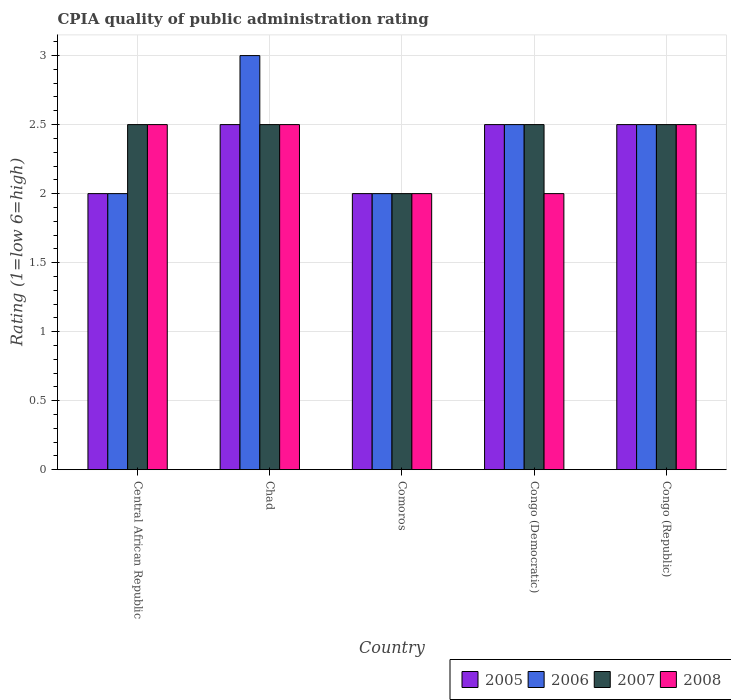How many different coloured bars are there?
Your answer should be compact. 4. How many groups of bars are there?
Your answer should be very brief. 5. Are the number of bars per tick equal to the number of legend labels?
Provide a short and direct response. Yes. Are the number of bars on each tick of the X-axis equal?
Offer a very short reply. Yes. How many bars are there on the 4th tick from the left?
Make the answer very short. 4. How many bars are there on the 1st tick from the right?
Provide a succinct answer. 4. What is the label of the 3rd group of bars from the left?
Offer a terse response. Comoros. Across all countries, what is the maximum CPIA rating in 2005?
Give a very brief answer. 2.5. Across all countries, what is the minimum CPIA rating in 2008?
Offer a terse response. 2. In which country was the CPIA rating in 2007 maximum?
Ensure brevity in your answer.  Central African Republic. In which country was the CPIA rating in 2005 minimum?
Keep it short and to the point. Central African Republic. What is the total CPIA rating in 2005 in the graph?
Provide a succinct answer. 11.5. What is the difference between the CPIA rating in 2008 in Comoros and the CPIA rating in 2006 in Congo (Republic)?
Offer a very short reply. -0.5. What is the average CPIA rating in 2006 per country?
Make the answer very short. 2.4. What is the difference between the CPIA rating of/in 2006 and CPIA rating of/in 2005 in Congo (Democratic)?
Offer a terse response. 0. What is the ratio of the CPIA rating in 2005 in Central African Republic to that in Congo (Republic)?
Make the answer very short. 0.8. Is the difference between the CPIA rating in 2006 in Comoros and Congo (Democratic) greater than the difference between the CPIA rating in 2005 in Comoros and Congo (Democratic)?
Offer a very short reply. No. What is the difference between the highest and the second highest CPIA rating in 2006?
Your answer should be compact. -0.5. What is the difference between the highest and the lowest CPIA rating in 2006?
Keep it short and to the point. 1. In how many countries, is the CPIA rating in 2008 greater than the average CPIA rating in 2008 taken over all countries?
Give a very brief answer. 3. Is the sum of the CPIA rating in 2005 in Comoros and Congo (Republic) greater than the maximum CPIA rating in 2008 across all countries?
Provide a short and direct response. Yes. Are all the bars in the graph horizontal?
Keep it short and to the point. No. Are the values on the major ticks of Y-axis written in scientific E-notation?
Your response must be concise. No. Does the graph contain grids?
Your response must be concise. Yes. Where does the legend appear in the graph?
Your answer should be compact. Bottom right. How many legend labels are there?
Your response must be concise. 4. What is the title of the graph?
Your response must be concise. CPIA quality of public administration rating. Does "1990" appear as one of the legend labels in the graph?
Your answer should be compact. No. What is the label or title of the X-axis?
Provide a short and direct response. Country. What is the Rating (1=low 6=high) in 2005 in Central African Republic?
Provide a succinct answer. 2. What is the Rating (1=low 6=high) of 2006 in Central African Republic?
Offer a terse response. 2. What is the Rating (1=low 6=high) of 2008 in Central African Republic?
Provide a succinct answer. 2.5. What is the Rating (1=low 6=high) in 2005 in Chad?
Make the answer very short. 2.5. What is the Rating (1=low 6=high) in 2006 in Chad?
Your answer should be compact. 3. What is the Rating (1=low 6=high) of 2007 in Chad?
Give a very brief answer. 2.5. What is the Rating (1=low 6=high) of 2008 in Chad?
Keep it short and to the point. 2.5. What is the Rating (1=low 6=high) in 2005 in Comoros?
Your answer should be very brief. 2. What is the Rating (1=low 6=high) in 2006 in Comoros?
Make the answer very short. 2. What is the Rating (1=low 6=high) of 2006 in Congo (Democratic)?
Keep it short and to the point. 2.5. What is the Rating (1=low 6=high) in 2008 in Congo (Democratic)?
Give a very brief answer. 2. What is the Rating (1=low 6=high) of 2005 in Congo (Republic)?
Ensure brevity in your answer.  2.5. What is the Rating (1=low 6=high) of 2007 in Congo (Republic)?
Your answer should be very brief. 2.5. Across all countries, what is the maximum Rating (1=low 6=high) in 2005?
Offer a very short reply. 2.5. Across all countries, what is the maximum Rating (1=low 6=high) of 2006?
Make the answer very short. 3. Across all countries, what is the maximum Rating (1=low 6=high) of 2007?
Provide a short and direct response. 2.5. Across all countries, what is the minimum Rating (1=low 6=high) of 2005?
Provide a short and direct response. 2. Across all countries, what is the minimum Rating (1=low 6=high) of 2006?
Ensure brevity in your answer.  2. What is the total Rating (1=low 6=high) in 2007 in the graph?
Your answer should be very brief. 12. What is the total Rating (1=low 6=high) in 2008 in the graph?
Your answer should be very brief. 11.5. What is the difference between the Rating (1=low 6=high) in 2006 in Central African Republic and that in Chad?
Make the answer very short. -1. What is the difference between the Rating (1=low 6=high) of 2005 in Central African Republic and that in Comoros?
Offer a very short reply. 0. What is the difference between the Rating (1=low 6=high) of 2006 in Central African Republic and that in Comoros?
Provide a short and direct response. 0. What is the difference between the Rating (1=low 6=high) in 2007 in Central African Republic and that in Congo (Democratic)?
Provide a succinct answer. 0. What is the difference between the Rating (1=low 6=high) in 2005 in Central African Republic and that in Congo (Republic)?
Give a very brief answer. -0.5. What is the difference between the Rating (1=low 6=high) in 2006 in Central African Republic and that in Congo (Republic)?
Your answer should be very brief. -0.5. What is the difference between the Rating (1=low 6=high) of 2008 in Central African Republic and that in Congo (Republic)?
Your response must be concise. 0. What is the difference between the Rating (1=low 6=high) in 2005 in Chad and that in Comoros?
Your answer should be compact. 0.5. What is the difference between the Rating (1=low 6=high) in 2005 in Chad and that in Congo (Democratic)?
Ensure brevity in your answer.  0. What is the difference between the Rating (1=low 6=high) in 2006 in Chad and that in Congo (Democratic)?
Keep it short and to the point. 0.5. What is the difference between the Rating (1=low 6=high) in 2007 in Chad and that in Congo (Democratic)?
Your response must be concise. 0. What is the difference between the Rating (1=low 6=high) in 2008 in Chad and that in Congo (Democratic)?
Give a very brief answer. 0.5. What is the difference between the Rating (1=low 6=high) of 2005 in Chad and that in Congo (Republic)?
Make the answer very short. 0. What is the difference between the Rating (1=low 6=high) in 2006 in Chad and that in Congo (Republic)?
Your answer should be compact. 0.5. What is the difference between the Rating (1=low 6=high) in 2007 in Chad and that in Congo (Republic)?
Keep it short and to the point. 0. What is the difference between the Rating (1=low 6=high) in 2005 in Comoros and that in Congo (Democratic)?
Offer a very short reply. -0.5. What is the difference between the Rating (1=low 6=high) of 2005 in Comoros and that in Congo (Republic)?
Keep it short and to the point. -0.5. What is the difference between the Rating (1=low 6=high) in 2007 in Comoros and that in Congo (Republic)?
Your answer should be very brief. -0.5. What is the difference between the Rating (1=low 6=high) of 2008 in Comoros and that in Congo (Republic)?
Make the answer very short. -0.5. What is the difference between the Rating (1=low 6=high) of 2006 in Congo (Democratic) and that in Congo (Republic)?
Your response must be concise. 0. What is the difference between the Rating (1=low 6=high) in 2008 in Congo (Democratic) and that in Congo (Republic)?
Your answer should be compact. -0.5. What is the difference between the Rating (1=low 6=high) of 2005 in Central African Republic and the Rating (1=low 6=high) of 2007 in Chad?
Offer a terse response. -0.5. What is the difference between the Rating (1=low 6=high) in 2005 in Central African Republic and the Rating (1=low 6=high) in 2008 in Chad?
Your answer should be compact. -0.5. What is the difference between the Rating (1=low 6=high) of 2006 in Central African Republic and the Rating (1=low 6=high) of 2007 in Chad?
Offer a very short reply. -0.5. What is the difference between the Rating (1=low 6=high) of 2006 in Central African Republic and the Rating (1=low 6=high) of 2008 in Chad?
Make the answer very short. -0.5. What is the difference between the Rating (1=low 6=high) of 2005 in Central African Republic and the Rating (1=low 6=high) of 2007 in Comoros?
Offer a very short reply. 0. What is the difference between the Rating (1=low 6=high) of 2005 in Central African Republic and the Rating (1=low 6=high) of 2008 in Comoros?
Your answer should be compact. 0. What is the difference between the Rating (1=low 6=high) in 2005 in Central African Republic and the Rating (1=low 6=high) in 2007 in Congo (Democratic)?
Give a very brief answer. -0.5. What is the difference between the Rating (1=low 6=high) of 2006 in Central African Republic and the Rating (1=low 6=high) of 2007 in Congo (Democratic)?
Your response must be concise. -0.5. What is the difference between the Rating (1=low 6=high) in 2007 in Central African Republic and the Rating (1=low 6=high) in 2008 in Congo (Democratic)?
Keep it short and to the point. 0.5. What is the difference between the Rating (1=low 6=high) of 2005 in Central African Republic and the Rating (1=low 6=high) of 2006 in Congo (Republic)?
Ensure brevity in your answer.  -0.5. What is the difference between the Rating (1=low 6=high) of 2005 in Chad and the Rating (1=low 6=high) of 2006 in Comoros?
Make the answer very short. 0.5. What is the difference between the Rating (1=low 6=high) of 2005 in Chad and the Rating (1=low 6=high) of 2007 in Comoros?
Ensure brevity in your answer.  0.5. What is the difference between the Rating (1=low 6=high) of 2005 in Chad and the Rating (1=low 6=high) of 2008 in Comoros?
Provide a short and direct response. 0.5. What is the difference between the Rating (1=low 6=high) in 2007 in Chad and the Rating (1=low 6=high) in 2008 in Comoros?
Ensure brevity in your answer.  0.5. What is the difference between the Rating (1=low 6=high) of 2005 in Chad and the Rating (1=low 6=high) of 2006 in Congo (Democratic)?
Ensure brevity in your answer.  0. What is the difference between the Rating (1=low 6=high) of 2005 in Chad and the Rating (1=low 6=high) of 2008 in Congo (Democratic)?
Your answer should be very brief. 0.5. What is the difference between the Rating (1=low 6=high) of 2006 in Chad and the Rating (1=low 6=high) of 2008 in Congo (Democratic)?
Provide a succinct answer. 1. What is the difference between the Rating (1=low 6=high) of 2007 in Chad and the Rating (1=low 6=high) of 2008 in Congo (Democratic)?
Provide a short and direct response. 0.5. What is the difference between the Rating (1=low 6=high) in 2005 in Chad and the Rating (1=low 6=high) in 2006 in Congo (Republic)?
Offer a terse response. 0. What is the difference between the Rating (1=low 6=high) of 2005 in Chad and the Rating (1=low 6=high) of 2007 in Congo (Republic)?
Offer a terse response. 0. What is the difference between the Rating (1=low 6=high) in 2005 in Chad and the Rating (1=low 6=high) in 2008 in Congo (Republic)?
Your answer should be compact. 0. What is the difference between the Rating (1=low 6=high) in 2007 in Chad and the Rating (1=low 6=high) in 2008 in Congo (Republic)?
Ensure brevity in your answer.  0. What is the difference between the Rating (1=low 6=high) of 2005 in Comoros and the Rating (1=low 6=high) of 2006 in Congo (Democratic)?
Provide a short and direct response. -0.5. What is the difference between the Rating (1=low 6=high) in 2005 in Comoros and the Rating (1=low 6=high) in 2007 in Congo (Democratic)?
Your response must be concise. -0.5. What is the difference between the Rating (1=low 6=high) in 2006 in Comoros and the Rating (1=low 6=high) in 2008 in Congo (Democratic)?
Ensure brevity in your answer.  0. What is the difference between the Rating (1=low 6=high) of 2007 in Comoros and the Rating (1=low 6=high) of 2008 in Congo (Democratic)?
Provide a short and direct response. 0. What is the difference between the Rating (1=low 6=high) in 2005 in Comoros and the Rating (1=low 6=high) in 2007 in Congo (Republic)?
Ensure brevity in your answer.  -0.5. What is the difference between the Rating (1=low 6=high) of 2005 in Comoros and the Rating (1=low 6=high) of 2008 in Congo (Republic)?
Make the answer very short. -0.5. What is the difference between the Rating (1=low 6=high) of 2006 in Comoros and the Rating (1=low 6=high) of 2008 in Congo (Republic)?
Your response must be concise. -0.5. What is the difference between the Rating (1=low 6=high) of 2007 in Comoros and the Rating (1=low 6=high) of 2008 in Congo (Republic)?
Ensure brevity in your answer.  -0.5. What is the difference between the Rating (1=low 6=high) in 2005 in Congo (Democratic) and the Rating (1=low 6=high) in 2006 in Congo (Republic)?
Offer a terse response. 0. What is the difference between the Rating (1=low 6=high) of 2006 in Congo (Democratic) and the Rating (1=low 6=high) of 2008 in Congo (Republic)?
Offer a terse response. 0. What is the average Rating (1=low 6=high) in 2008 per country?
Ensure brevity in your answer.  2.3. What is the difference between the Rating (1=low 6=high) in 2005 and Rating (1=low 6=high) in 2006 in Central African Republic?
Your response must be concise. 0. What is the difference between the Rating (1=low 6=high) in 2007 and Rating (1=low 6=high) in 2008 in Central African Republic?
Your answer should be very brief. 0. What is the difference between the Rating (1=low 6=high) of 2005 and Rating (1=low 6=high) of 2008 in Chad?
Provide a succinct answer. 0. What is the difference between the Rating (1=low 6=high) in 2006 and Rating (1=low 6=high) in 2007 in Chad?
Ensure brevity in your answer.  0.5. What is the difference between the Rating (1=low 6=high) in 2007 and Rating (1=low 6=high) in 2008 in Chad?
Offer a terse response. 0. What is the difference between the Rating (1=low 6=high) in 2006 and Rating (1=low 6=high) in 2008 in Comoros?
Provide a short and direct response. 0. What is the difference between the Rating (1=low 6=high) of 2007 and Rating (1=low 6=high) of 2008 in Comoros?
Offer a terse response. 0. What is the difference between the Rating (1=low 6=high) in 2005 and Rating (1=low 6=high) in 2007 in Congo (Democratic)?
Keep it short and to the point. 0. What is the difference between the Rating (1=low 6=high) in 2005 and Rating (1=low 6=high) in 2008 in Congo (Democratic)?
Ensure brevity in your answer.  0.5. What is the difference between the Rating (1=low 6=high) in 2006 and Rating (1=low 6=high) in 2008 in Congo (Democratic)?
Offer a very short reply. 0.5. What is the difference between the Rating (1=low 6=high) of 2007 and Rating (1=low 6=high) of 2008 in Congo (Democratic)?
Provide a short and direct response. 0.5. What is the difference between the Rating (1=low 6=high) of 2005 and Rating (1=low 6=high) of 2007 in Congo (Republic)?
Give a very brief answer. 0. What is the difference between the Rating (1=low 6=high) of 2005 and Rating (1=low 6=high) of 2008 in Congo (Republic)?
Give a very brief answer. 0. What is the difference between the Rating (1=low 6=high) in 2006 and Rating (1=low 6=high) in 2007 in Congo (Republic)?
Keep it short and to the point. 0. What is the difference between the Rating (1=low 6=high) of 2007 and Rating (1=low 6=high) of 2008 in Congo (Republic)?
Keep it short and to the point. 0. What is the ratio of the Rating (1=low 6=high) in 2008 in Central African Republic to that in Chad?
Ensure brevity in your answer.  1. What is the ratio of the Rating (1=low 6=high) of 2008 in Central African Republic to that in Comoros?
Make the answer very short. 1.25. What is the ratio of the Rating (1=low 6=high) of 2005 in Central African Republic to that in Congo (Democratic)?
Give a very brief answer. 0.8. What is the ratio of the Rating (1=low 6=high) of 2007 in Central African Republic to that in Congo (Republic)?
Your response must be concise. 1. What is the ratio of the Rating (1=low 6=high) in 2008 in Central African Republic to that in Congo (Republic)?
Ensure brevity in your answer.  1. What is the ratio of the Rating (1=low 6=high) of 2005 in Chad to that in Comoros?
Offer a terse response. 1.25. What is the ratio of the Rating (1=low 6=high) in 2006 in Chad to that in Comoros?
Your response must be concise. 1.5. What is the ratio of the Rating (1=low 6=high) of 2007 in Chad to that in Congo (Democratic)?
Offer a very short reply. 1. What is the ratio of the Rating (1=low 6=high) in 2008 in Chad to that in Congo (Democratic)?
Your answer should be very brief. 1.25. What is the ratio of the Rating (1=low 6=high) of 2005 in Chad to that in Congo (Republic)?
Make the answer very short. 1. What is the ratio of the Rating (1=low 6=high) of 2007 in Chad to that in Congo (Republic)?
Your answer should be compact. 1. What is the ratio of the Rating (1=low 6=high) of 2005 in Comoros to that in Congo (Democratic)?
Your answer should be very brief. 0.8. What is the ratio of the Rating (1=low 6=high) in 2005 in Comoros to that in Congo (Republic)?
Offer a very short reply. 0.8. What is the ratio of the Rating (1=low 6=high) in 2006 in Comoros to that in Congo (Republic)?
Offer a terse response. 0.8. What is the ratio of the Rating (1=low 6=high) in 2005 in Congo (Democratic) to that in Congo (Republic)?
Provide a succinct answer. 1. What is the ratio of the Rating (1=low 6=high) in 2006 in Congo (Democratic) to that in Congo (Republic)?
Your response must be concise. 1. What is the ratio of the Rating (1=low 6=high) of 2007 in Congo (Democratic) to that in Congo (Republic)?
Keep it short and to the point. 1. What is the difference between the highest and the second highest Rating (1=low 6=high) in 2005?
Keep it short and to the point. 0. What is the difference between the highest and the second highest Rating (1=low 6=high) of 2006?
Give a very brief answer. 0.5. What is the difference between the highest and the second highest Rating (1=low 6=high) in 2007?
Ensure brevity in your answer.  0. What is the difference between the highest and the lowest Rating (1=low 6=high) in 2005?
Offer a very short reply. 0.5. What is the difference between the highest and the lowest Rating (1=low 6=high) of 2006?
Keep it short and to the point. 1. 